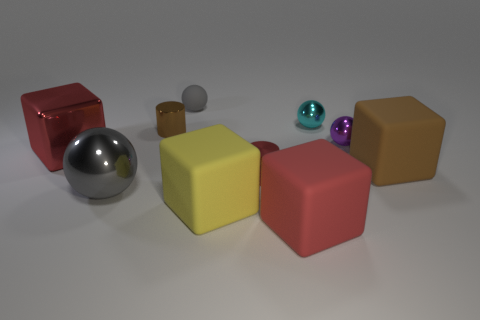Describe the lighting and shadows in the image. The lighting in the image seems to come from above, casting gentle shadows to the right of the objects, indicating the light source is to the left. The shadows are soft and diffused, suggesting a broad non-point light source. 